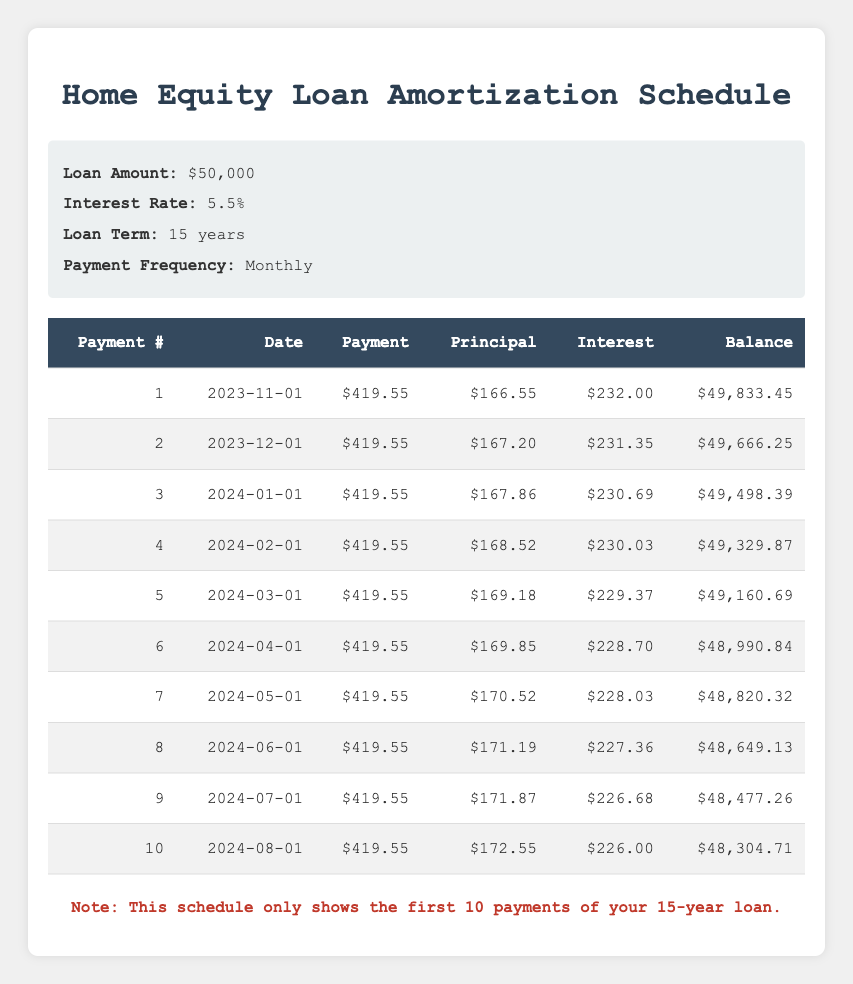What is the payment amount for the first month? Looking at the table, in the first row under the "Payment" column, the value is $419.55.
Answer: $419.55 How much of the second payment goes toward the principal? In the second row, under the "Principal" column, the value is $167.20.
Answer: $167.20 What is the remaining balance after the third payment? In the third row, the "Balance" column indicates the remaining balance is $49,498.39.
Answer: $49,498.39 Is the interest payment for the first month greater than $230? The interest payment for the first month is $232.00, which is indeed greater than $230.
Answer: Yes What is the total amount of principal paid in the first 10 payments? To find the total principal for the first 10 payments, we sum the "Principal" values from rows 1 to 10: 166.55 + 167.20 + 167.86 + 168.52 + 169.18 + 169.85 + 170.52 + 171.19 + 171.87 + 172.55 = 1,686.29.
Answer: $1,686.29 What is the average interest payment for the first 10 months? We calculate the average interest payment by summing the "Interest" values: (232.00 + 231.35 + 230.69 + 230.03 + 229.37 + 228.70 + 228.03 + 227.36 + 226.68 + 226.00) = 2,457.21, and then divide by 10, to get an average of 245.72.
Answer: $245.72 After the 10th payment, what is the new remaining balance? The table shows that after the 10th payment, the remaining balance is $48,304.71 as indicated in the "Balance" column of row 10.
Answer: $48,304.71 Is there a point at which the principal payment exceeds $170? Yes, according to the table, the principal payments exceed $170 starting from payment number 7, where it is $170.52.
Answer: Yes What is the difference in the interest payment between the first and fifth months? The difference is calculated by subtracting the interest payment of the fifth month ($229.37) from the first month ($232.00): 232.00 - 229.37 = 2.63.
Answer: $2.63 